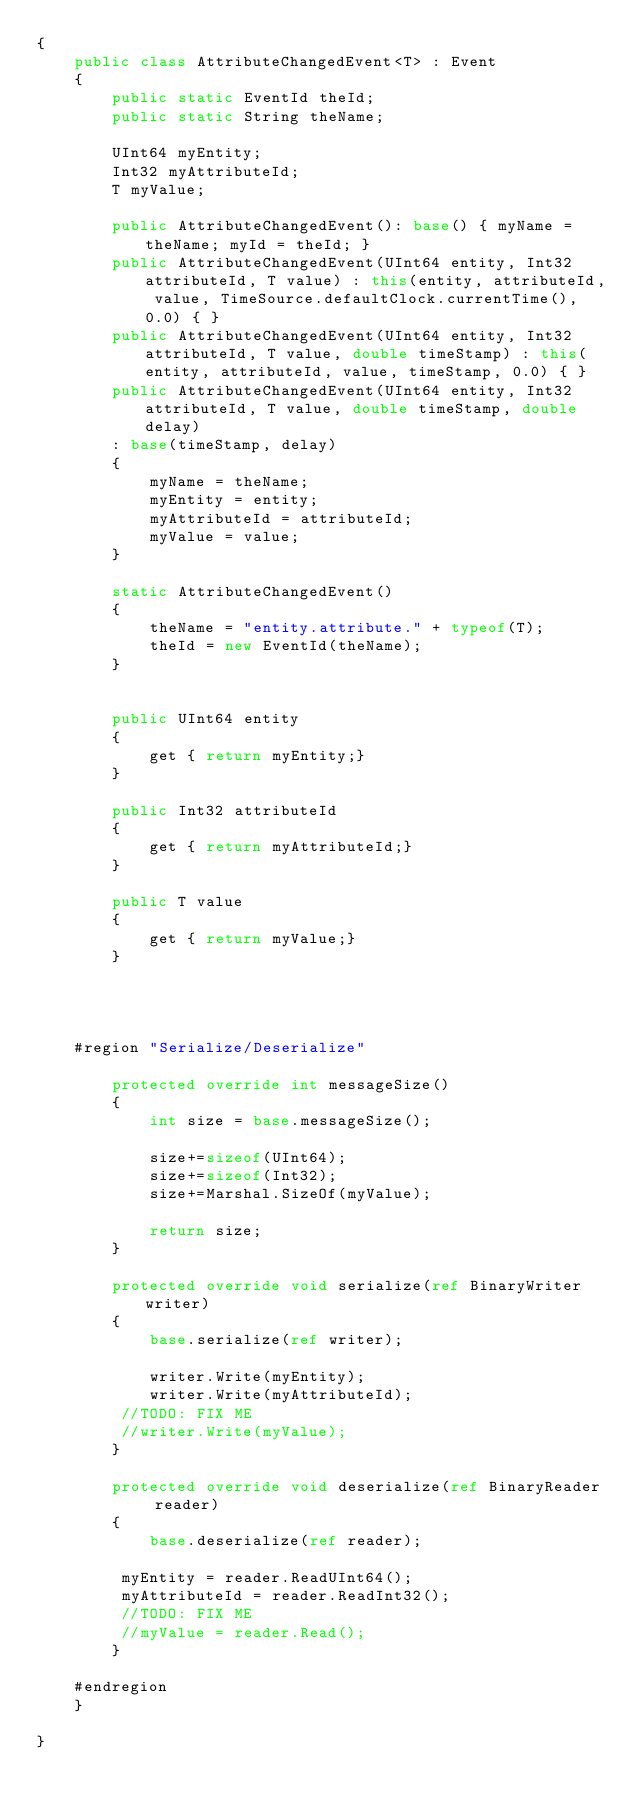<code> <loc_0><loc_0><loc_500><loc_500><_C#_>{
	public class AttributeChangedEvent<T> : Event
	{
		public static EventId theId;
		public static String theName;

		UInt64 myEntity;
		Int32 myAttributeId;
		T myValue;

		public AttributeChangedEvent(): base() { myName = theName; myId = theId; }
		public AttributeChangedEvent(UInt64 entity, Int32 attributeId, T value) : this(entity, attributeId, value, TimeSource.defaultClock.currentTime(), 0.0) { }
		public AttributeChangedEvent(UInt64 entity, Int32 attributeId, T value, double timeStamp) : this(entity, attributeId, value, timeStamp, 0.0) { }
		public AttributeChangedEvent(UInt64 entity, Int32 attributeId, T value, double timeStamp, double delay)
		: base(timeStamp, delay)
		{
			myName = theName;
			myEntity = entity;
			myAttributeId = attributeId;
			myValue = value;
		}

		static AttributeChangedEvent()
		{
			theName = "entity.attribute." + typeof(T);
			theId = new EventId(theName);
		}


		public UInt64 entity
		{
			get { return myEntity;}
		}
	
		public Int32 attributeId
		{
			get { return myAttributeId;}
		}
	
		public T value
		{
			get { return myValue;}
		}
	



	#region "Serialize/Deserialize"

		protected override int messageSize()
		{
			int size = base.messageSize();

			size+=sizeof(UInt64);
			size+=sizeof(Int32);
			size+=Marshal.SizeOf(myValue);

			return size;
		}

		protected override void serialize(ref BinaryWriter writer)
		{
			base.serialize(ref writer);

			writer.Write(myEntity);
			writer.Write(myAttributeId);
         //TODO: FIX ME
         //writer.Write(myValue);
		}

		protected override void deserialize(ref BinaryReader reader)
		{
			base.deserialize(ref reader);

         myEntity = reader.ReadUInt64();
         myAttributeId = reader.ReadInt32();
         //TODO: FIX ME
         //myValue = reader.Read();
		}

	#endregion
	}
	
}

	</code> 